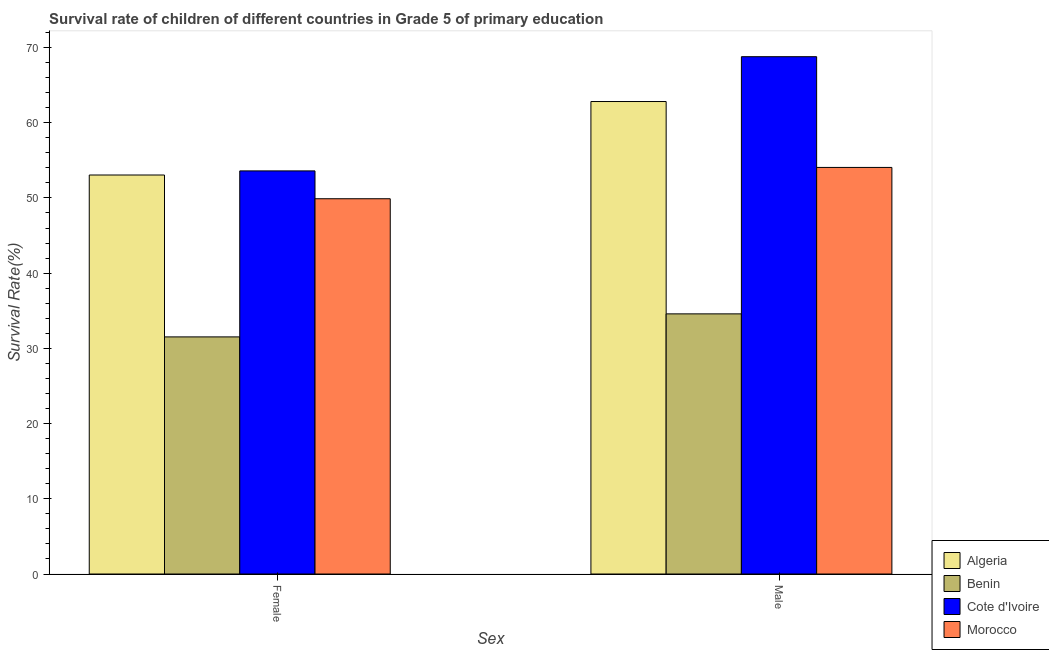How many groups of bars are there?
Your answer should be compact. 2. Are the number of bars on each tick of the X-axis equal?
Provide a short and direct response. Yes. How many bars are there on the 2nd tick from the left?
Your response must be concise. 4. What is the survival rate of male students in primary education in Benin?
Make the answer very short. 34.58. Across all countries, what is the maximum survival rate of female students in primary education?
Offer a very short reply. 53.59. Across all countries, what is the minimum survival rate of female students in primary education?
Provide a succinct answer. 31.52. In which country was the survival rate of male students in primary education maximum?
Keep it short and to the point. Cote d'Ivoire. In which country was the survival rate of female students in primary education minimum?
Offer a very short reply. Benin. What is the total survival rate of male students in primary education in the graph?
Your response must be concise. 220.23. What is the difference between the survival rate of male students in primary education in Morocco and that in Benin?
Offer a terse response. 19.47. What is the difference between the survival rate of male students in primary education in Morocco and the survival rate of female students in primary education in Benin?
Ensure brevity in your answer.  22.53. What is the average survival rate of male students in primary education per country?
Give a very brief answer. 55.06. What is the difference between the survival rate of male students in primary education and survival rate of female students in primary education in Algeria?
Offer a terse response. 9.77. In how many countries, is the survival rate of male students in primary education greater than 60 %?
Your response must be concise. 2. What is the ratio of the survival rate of female students in primary education in Algeria to that in Cote d'Ivoire?
Provide a short and direct response. 0.99. Is the survival rate of male students in primary education in Morocco less than that in Benin?
Provide a short and direct response. No. In how many countries, is the survival rate of female students in primary education greater than the average survival rate of female students in primary education taken over all countries?
Your answer should be compact. 3. What does the 4th bar from the left in Female represents?
Ensure brevity in your answer.  Morocco. What does the 2nd bar from the right in Female represents?
Give a very brief answer. Cote d'Ivoire. How many bars are there?
Give a very brief answer. 8. Are all the bars in the graph horizontal?
Ensure brevity in your answer.  No. What is the difference between two consecutive major ticks on the Y-axis?
Provide a succinct answer. 10. Does the graph contain any zero values?
Your answer should be very brief. No. How are the legend labels stacked?
Ensure brevity in your answer.  Vertical. What is the title of the graph?
Your answer should be very brief. Survival rate of children of different countries in Grade 5 of primary education. What is the label or title of the X-axis?
Keep it short and to the point. Sex. What is the label or title of the Y-axis?
Offer a very short reply. Survival Rate(%). What is the Survival Rate(%) in Algeria in Female?
Keep it short and to the point. 53.04. What is the Survival Rate(%) of Benin in Female?
Offer a terse response. 31.52. What is the Survival Rate(%) of Cote d'Ivoire in Female?
Make the answer very short. 53.59. What is the Survival Rate(%) of Morocco in Female?
Give a very brief answer. 49.89. What is the Survival Rate(%) in Algeria in Male?
Your response must be concise. 62.82. What is the Survival Rate(%) in Benin in Male?
Give a very brief answer. 34.58. What is the Survival Rate(%) in Cote d'Ivoire in Male?
Provide a short and direct response. 68.78. What is the Survival Rate(%) in Morocco in Male?
Keep it short and to the point. 54.05. Across all Sex, what is the maximum Survival Rate(%) of Algeria?
Provide a succinct answer. 62.82. Across all Sex, what is the maximum Survival Rate(%) in Benin?
Ensure brevity in your answer.  34.58. Across all Sex, what is the maximum Survival Rate(%) in Cote d'Ivoire?
Give a very brief answer. 68.78. Across all Sex, what is the maximum Survival Rate(%) in Morocco?
Your answer should be very brief. 54.05. Across all Sex, what is the minimum Survival Rate(%) of Algeria?
Make the answer very short. 53.04. Across all Sex, what is the minimum Survival Rate(%) in Benin?
Give a very brief answer. 31.52. Across all Sex, what is the minimum Survival Rate(%) in Cote d'Ivoire?
Your response must be concise. 53.59. Across all Sex, what is the minimum Survival Rate(%) of Morocco?
Make the answer very short. 49.89. What is the total Survival Rate(%) in Algeria in the graph?
Provide a short and direct response. 115.86. What is the total Survival Rate(%) in Benin in the graph?
Your answer should be compact. 66.11. What is the total Survival Rate(%) in Cote d'Ivoire in the graph?
Provide a short and direct response. 122.37. What is the total Survival Rate(%) of Morocco in the graph?
Keep it short and to the point. 103.94. What is the difference between the Survival Rate(%) of Algeria in Female and that in Male?
Your answer should be compact. -9.77. What is the difference between the Survival Rate(%) of Benin in Female and that in Male?
Your response must be concise. -3.06. What is the difference between the Survival Rate(%) of Cote d'Ivoire in Female and that in Male?
Offer a very short reply. -15.18. What is the difference between the Survival Rate(%) in Morocco in Female and that in Male?
Your answer should be very brief. -4.16. What is the difference between the Survival Rate(%) in Algeria in Female and the Survival Rate(%) in Benin in Male?
Your answer should be very brief. 18.46. What is the difference between the Survival Rate(%) of Algeria in Female and the Survival Rate(%) of Cote d'Ivoire in Male?
Your answer should be compact. -15.73. What is the difference between the Survival Rate(%) of Algeria in Female and the Survival Rate(%) of Morocco in Male?
Offer a terse response. -1.01. What is the difference between the Survival Rate(%) in Benin in Female and the Survival Rate(%) in Cote d'Ivoire in Male?
Provide a succinct answer. -37.25. What is the difference between the Survival Rate(%) in Benin in Female and the Survival Rate(%) in Morocco in Male?
Provide a succinct answer. -22.53. What is the difference between the Survival Rate(%) of Cote d'Ivoire in Female and the Survival Rate(%) of Morocco in Male?
Offer a very short reply. -0.46. What is the average Survival Rate(%) in Algeria per Sex?
Provide a succinct answer. 57.93. What is the average Survival Rate(%) of Benin per Sex?
Offer a terse response. 33.05. What is the average Survival Rate(%) in Cote d'Ivoire per Sex?
Your answer should be very brief. 61.18. What is the average Survival Rate(%) of Morocco per Sex?
Ensure brevity in your answer.  51.97. What is the difference between the Survival Rate(%) in Algeria and Survival Rate(%) in Benin in Female?
Make the answer very short. 21.52. What is the difference between the Survival Rate(%) of Algeria and Survival Rate(%) of Cote d'Ivoire in Female?
Your response must be concise. -0.55. What is the difference between the Survival Rate(%) of Algeria and Survival Rate(%) of Morocco in Female?
Offer a terse response. 3.15. What is the difference between the Survival Rate(%) in Benin and Survival Rate(%) in Cote d'Ivoire in Female?
Keep it short and to the point. -22.07. What is the difference between the Survival Rate(%) in Benin and Survival Rate(%) in Morocco in Female?
Offer a terse response. -18.37. What is the difference between the Survival Rate(%) of Cote d'Ivoire and Survival Rate(%) of Morocco in Female?
Your answer should be compact. 3.7. What is the difference between the Survival Rate(%) of Algeria and Survival Rate(%) of Benin in Male?
Offer a terse response. 28.23. What is the difference between the Survival Rate(%) in Algeria and Survival Rate(%) in Cote d'Ivoire in Male?
Provide a short and direct response. -5.96. What is the difference between the Survival Rate(%) in Algeria and Survival Rate(%) in Morocco in Male?
Your answer should be very brief. 8.76. What is the difference between the Survival Rate(%) of Benin and Survival Rate(%) of Cote d'Ivoire in Male?
Offer a very short reply. -34.19. What is the difference between the Survival Rate(%) in Benin and Survival Rate(%) in Morocco in Male?
Provide a succinct answer. -19.47. What is the difference between the Survival Rate(%) of Cote d'Ivoire and Survival Rate(%) of Morocco in Male?
Give a very brief answer. 14.72. What is the ratio of the Survival Rate(%) in Algeria in Female to that in Male?
Make the answer very short. 0.84. What is the ratio of the Survival Rate(%) of Benin in Female to that in Male?
Keep it short and to the point. 0.91. What is the ratio of the Survival Rate(%) in Cote d'Ivoire in Female to that in Male?
Your answer should be very brief. 0.78. What is the ratio of the Survival Rate(%) of Morocco in Female to that in Male?
Your response must be concise. 0.92. What is the difference between the highest and the second highest Survival Rate(%) in Algeria?
Keep it short and to the point. 9.77. What is the difference between the highest and the second highest Survival Rate(%) in Benin?
Give a very brief answer. 3.06. What is the difference between the highest and the second highest Survival Rate(%) in Cote d'Ivoire?
Keep it short and to the point. 15.18. What is the difference between the highest and the second highest Survival Rate(%) in Morocco?
Make the answer very short. 4.16. What is the difference between the highest and the lowest Survival Rate(%) in Algeria?
Your answer should be compact. 9.77. What is the difference between the highest and the lowest Survival Rate(%) in Benin?
Give a very brief answer. 3.06. What is the difference between the highest and the lowest Survival Rate(%) of Cote d'Ivoire?
Provide a succinct answer. 15.18. What is the difference between the highest and the lowest Survival Rate(%) in Morocco?
Provide a short and direct response. 4.16. 